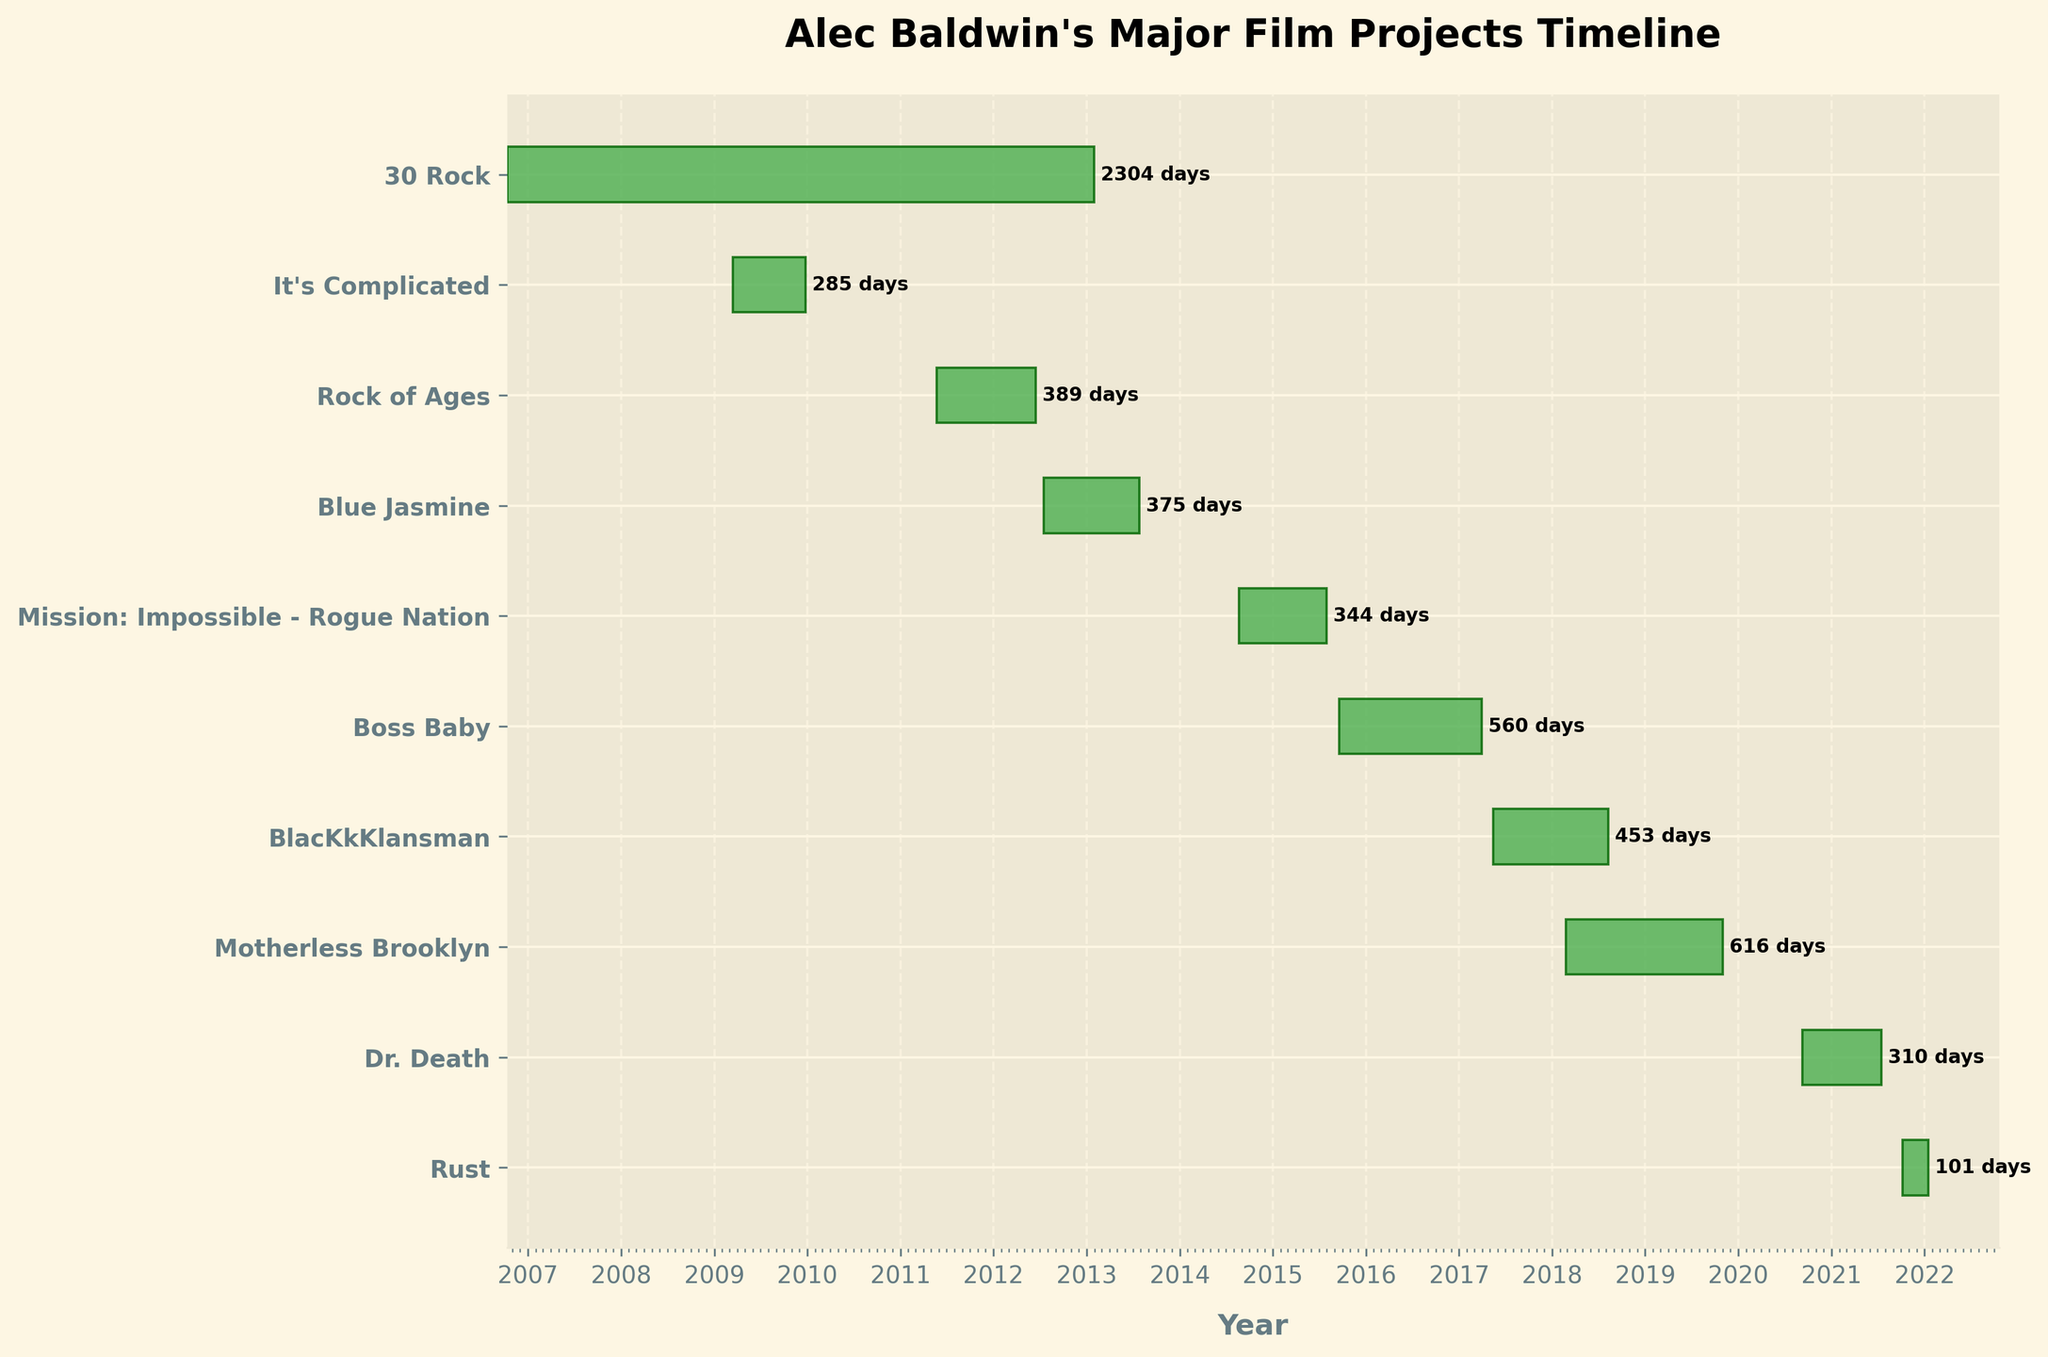How many major film projects of Alec Baldwin are shown in the figure? Count the number of distinct project titles listed along the y-axis of the Gantt chart.
Answer: 10 Which project had the longest duration? Look for the project that has the longest horizontal bar on the chart, indicating the duration from start to end.
Answer: 30 Rock What is the duration of the project "Rust"? Locate "Rust" on the y-axis, then check the length of the bar on the x-axis, and count the number of days between the start and end dates.
Answer: 101 days How many days did "Mission: Impossible - Rogue Nation" take from start to end? Identify the bar corresponding to "Mission: Impossible - Rogue Nation" and note the days indicated at the end of the bar.
Answer: 344 days Which project started first and which one started last? Identify the earliest and latest start points on the x-axis for the respective projects' bars.
Answer: "30 Rock" started first, and "Rust" started last What is the average duration of the projects shown? Calculate the duration for each project, sum these durations, and divide by the number of projects.
Answer: 355.6 days How many projects lasted over one year? Identify bars that extend beyond a single yearly tick mark on the x-axis, indicating more than 365 days.
Answer: 5 projects Which two projects had the closest start dates? Compare the start dates of all the projects and find the smallest interval between any two consecutive start dates.
Answer: "It's Complicated" and "30 Rock" How many projects overlapped in their timelines, and which ones? Look for any horizontal bars that overlap in their length on the x-axis.
Answer: 5 projects overlapped (e.g., "It's Complicated" overlapped with "30 Rock") 